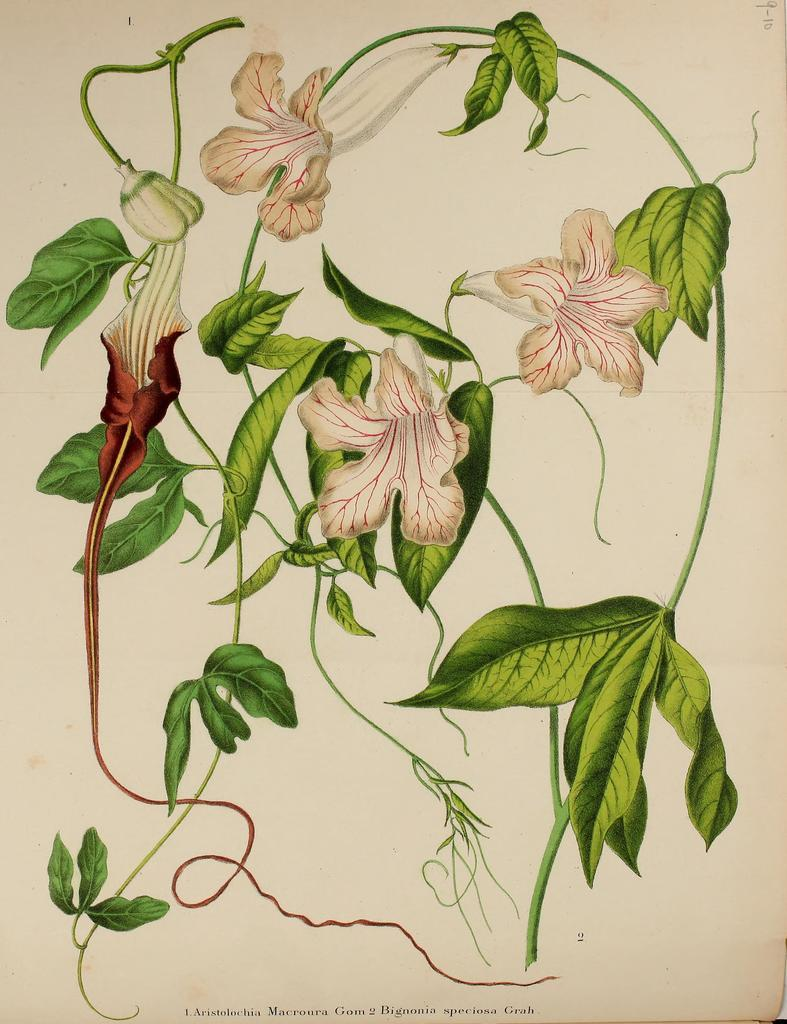What type of artwork is depicted in the image? The image is a painting. What natural elements are present in the painting? There are flowers and leaves in the painting. How many thumbs can be seen in the painting? There are no thumbs present in the painting, as it features flowers and leaves. 